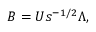Convert formula to latex. <formula><loc_0><loc_0><loc_500><loc_500>B = U s ^ { - 1 / 2 } \Lambda ,</formula> 